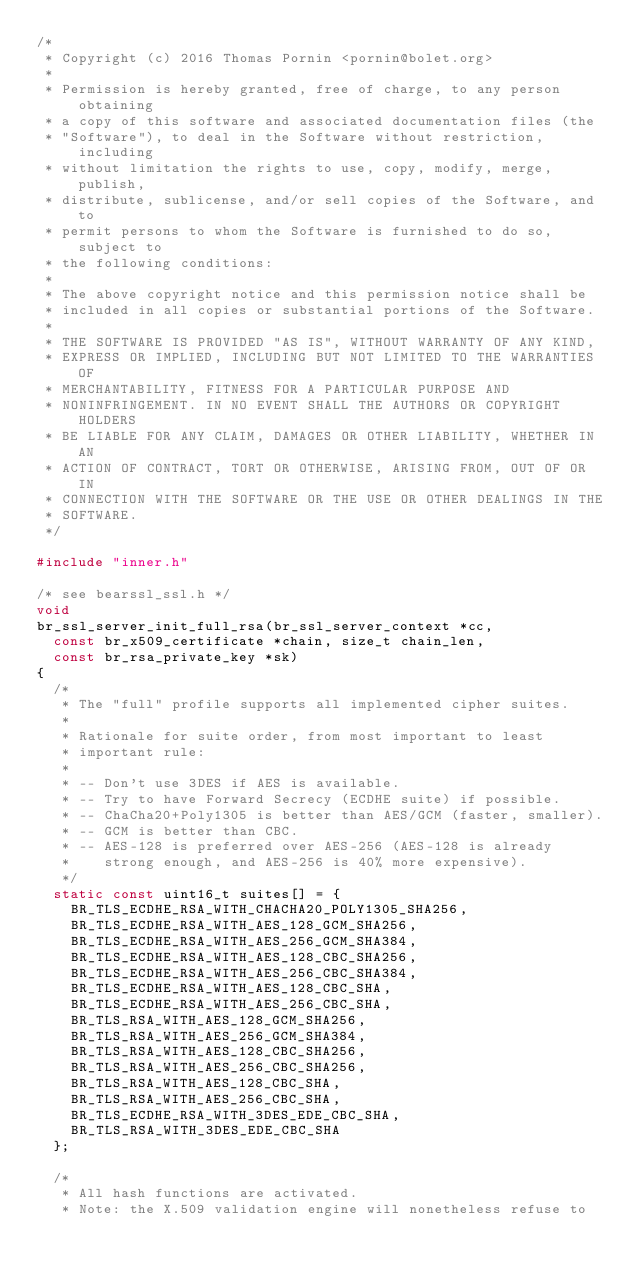Convert code to text. <code><loc_0><loc_0><loc_500><loc_500><_C_>/*
 * Copyright (c) 2016 Thomas Pornin <pornin@bolet.org>
 *
 * Permission is hereby granted, free of charge, to any person obtaining 
 * a copy of this software and associated documentation files (the
 * "Software"), to deal in the Software without restriction, including
 * without limitation the rights to use, copy, modify, merge, publish,
 * distribute, sublicense, and/or sell copies of the Software, and to
 * permit persons to whom the Software is furnished to do so, subject to
 * the following conditions:
 *
 * The above copyright notice and this permission notice shall be 
 * included in all copies or substantial portions of the Software.
 *
 * THE SOFTWARE IS PROVIDED "AS IS", WITHOUT WARRANTY OF ANY KIND, 
 * EXPRESS OR IMPLIED, INCLUDING BUT NOT LIMITED TO THE WARRANTIES OF
 * MERCHANTABILITY, FITNESS FOR A PARTICULAR PURPOSE AND 
 * NONINFRINGEMENT. IN NO EVENT SHALL THE AUTHORS OR COPYRIGHT HOLDERS
 * BE LIABLE FOR ANY CLAIM, DAMAGES OR OTHER LIABILITY, WHETHER IN AN
 * ACTION OF CONTRACT, TORT OR OTHERWISE, ARISING FROM, OUT OF OR IN
 * CONNECTION WITH THE SOFTWARE OR THE USE OR OTHER DEALINGS IN THE
 * SOFTWARE.
 */

#include "inner.h"

/* see bearssl_ssl.h */
void
br_ssl_server_init_full_rsa(br_ssl_server_context *cc,
	const br_x509_certificate *chain, size_t chain_len,
	const br_rsa_private_key *sk)
{
	/*
	 * The "full" profile supports all implemented cipher suites.
	 *
	 * Rationale for suite order, from most important to least
	 * important rule:
	 *
	 * -- Don't use 3DES if AES is available.
	 * -- Try to have Forward Secrecy (ECDHE suite) if possible.
	 * -- ChaCha20+Poly1305 is better than AES/GCM (faster, smaller).
	 * -- GCM is better than CBC.
	 * -- AES-128 is preferred over AES-256 (AES-128 is already
	 *    strong enough, and AES-256 is 40% more expensive).
	 */
	static const uint16_t suites[] = {
		BR_TLS_ECDHE_RSA_WITH_CHACHA20_POLY1305_SHA256,
		BR_TLS_ECDHE_RSA_WITH_AES_128_GCM_SHA256,
		BR_TLS_ECDHE_RSA_WITH_AES_256_GCM_SHA384,
		BR_TLS_ECDHE_RSA_WITH_AES_128_CBC_SHA256,
		BR_TLS_ECDHE_RSA_WITH_AES_256_CBC_SHA384,
		BR_TLS_ECDHE_RSA_WITH_AES_128_CBC_SHA,
		BR_TLS_ECDHE_RSA_WITH_AES_256_CBC_SHA,
		BR_TLS_RSA_WITH_AES_128_GCM_SHA256,
		BR_TLS_RSA_WITH_AES_256_GCM_SHA384,
		BR_TLS_RSA_WITH_AES_128_CBC_SHA256,
		BR_TLS_RSA_WITH_AES_256_CBC_SHA256,
		BR_TLS_RSA_WITH_AES_128_CBC_SHA,
		BR_TLS_RSA_WITH_AES_256_CBC_SHA,
		BR_TLS_ECDHE_RSA_WITH_3DES_EDE_CBC_SHA,
		BR_TLS_RSA_WITH_3DES_EDE_CBC_SHA
	};

	/*
	 * All hash functions are activated.
	 * Note: the X.509 validation engine will nonetheless refuse to</code> 